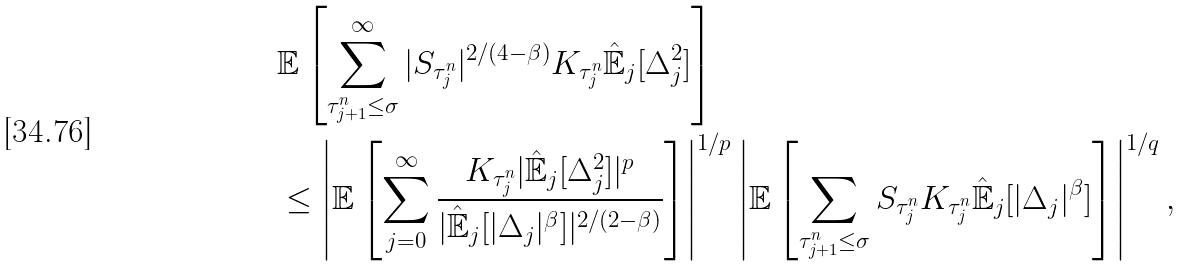<formula> <loc_0><loc_0><loc_500><loc_500>& \mathbb { E } \left [ \sum _ { \tau ^ { n } _ { j + 1 } \leq \sigma } ^ { \infty } | S _ { \tau ^ { n } _ { j } } | ^ { 2 / ( 4 - \beta ) } K _ { \tau ^ { n } _ { j } } \hat { \mathbb { E } } _ { j } [ \Delta _ { j } ^ { 2 } ] \right ] \\ & \leq \left | \mathbb { E } \left [ \sum _ { j = 0 } ^ { \infty } \frac { K _ { \tau ^ { n } _ { j } } | \hat { \mathbb { E } } _ { j } [ \Delta _ { j } ^ { 2 } ] | ^ { p } } { | \hat { \mathbb { E } } _ { j } [ | \Delta _ { j } | ^ { \beta } ] | ^ { 2 / ( 2 - \beta ) } } \right ] \right | ^ { 1 / p } \left | \mathbb { E } \left [ \sum _ { \tau ^ { n } _ { j + 1 } \leq \sigma } S _ { \tau ^ { n } _ { j } } K _ { \tau ^ { n } _ { j } } \hat { \mathbb { E } } _ { j } [ | \Delta _ { j } | ^ { \beta } ] \right ] \right | ^ { 1 / q } ,</formula> 